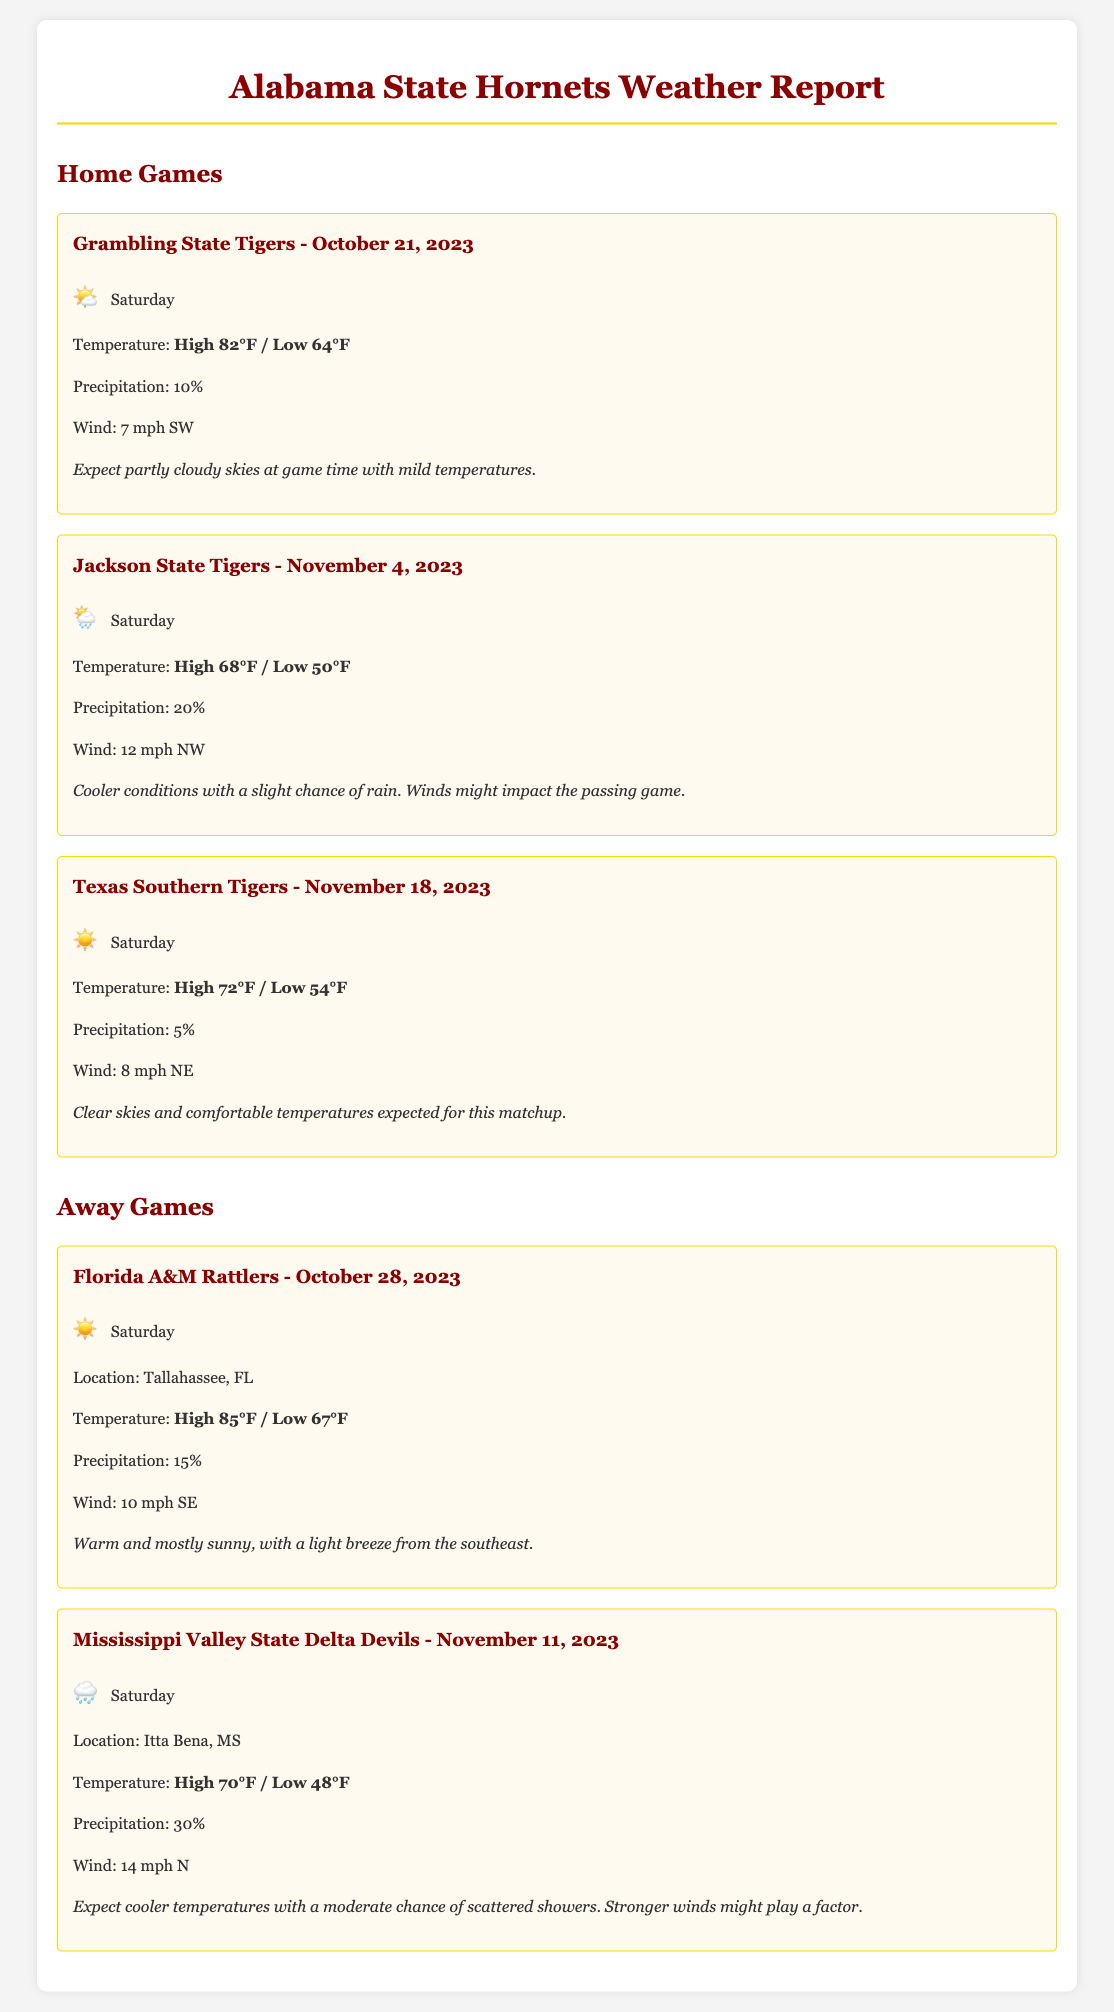what is the date of the game against Grambling State Tigers? The date of the game against Grambling State Tigers is mentioned in the document as October 21, 2023.
Answer: October 21, 2023 what is the expected high temperature for the away game against Florida A&M Rattlers? The expected high temperature for the away game against Florida A&M Rattlers is stated as 85°F.
Answer: 85°F what is the chance of precipitation during the Jackson State Tigers game? The chance of precipitation during the Jackson State Tigers game is reported as 20%.
Answer: 20% which game has the lowest expected temperature? The game with the lowest expected temperature is the Mississippi Valley State Delta Devils game with a low of 48°F.
Answer: 48°F how strong is the wind expected during the Texas Southern Tigers game? The expected wind speed during the Texas Southern Tigers game is mentioned as 8 mph NE.
Answer: 8 mph NE what type of weather is forecasted for the game against Texas Southern Tigers? The document states that clear skies and comfortable temperatures are expected for the game against Texas Southern Tigers.
Answer: Clear skies and comfortable temperatures how many away games are listed in the report? The report includes two away games listed in the document.
Answer: 2 what is the weather icon used for the home game against Jackson State Tigers? The weather icon used for the home game against Jackson State Tigers is represented as 🌦️.
Answer: 🌦️ 